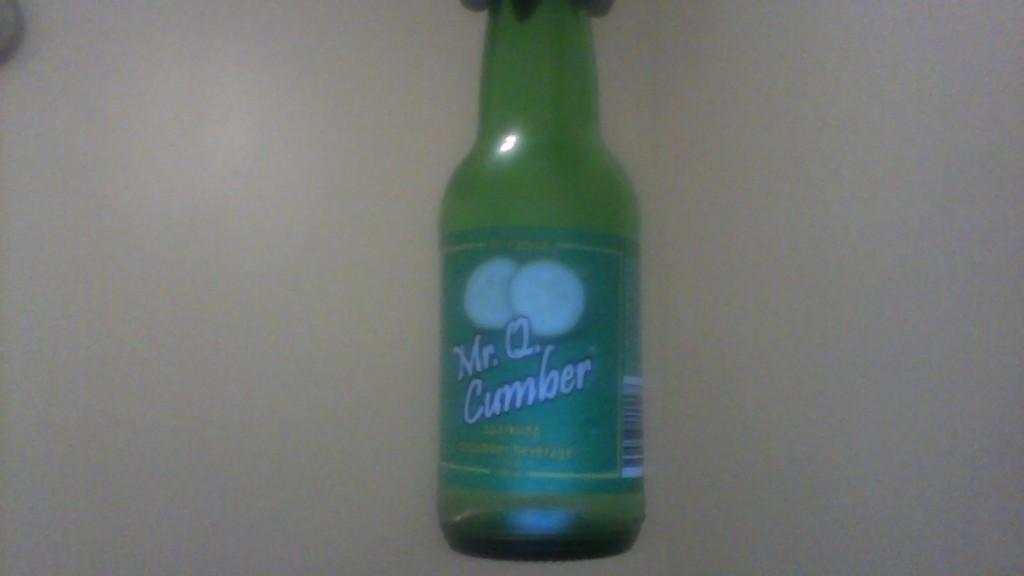What is the color of the bottle in the image? The bottle in the image is green. Is there any additional detail on the bottle? Yes, there is a sticker on the bottle. What is the color of the background in the image? The background of the image is white. What type of birthday cake is being cut by the aunt in the image? There is no aunt or birthday cake present in the image; it only features a green color bottle with a sticker on it and a white background. What type of blade is being used to cut the cake in the image? There is no cake or blade present in the image. 